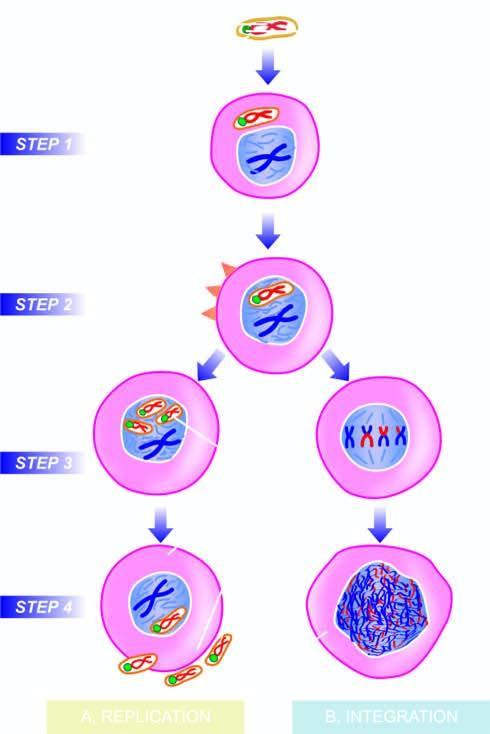re orms of assembled in the cell nucleus?
Answer the question using a single word or phrase. No 